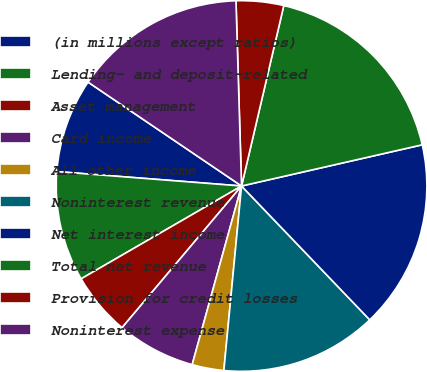Convert chart to OTSL. <chart><loc_0><loc_0><loc_500><loc_500><pie_chart><fcel>(in millions except ratios)<fcel>Lending- and deposit-related<fcel>Asset management<fcel>Card income<fcel>All other income<fcel>Noninterest revenue<fcel>Net interest income<fcel>Total net revenue<fcel>Provision for credit losses<fcel>Noninterest expense<nl><fcel>8.23%<fcel>9.59%<fcel>5.5%<fcel>6.86%<fcel>2.77%<fcel>13.68%<fcel>16.41%<fcel>17.77%<fcel>4.14%<fcel>15.05%<nl></chart> 